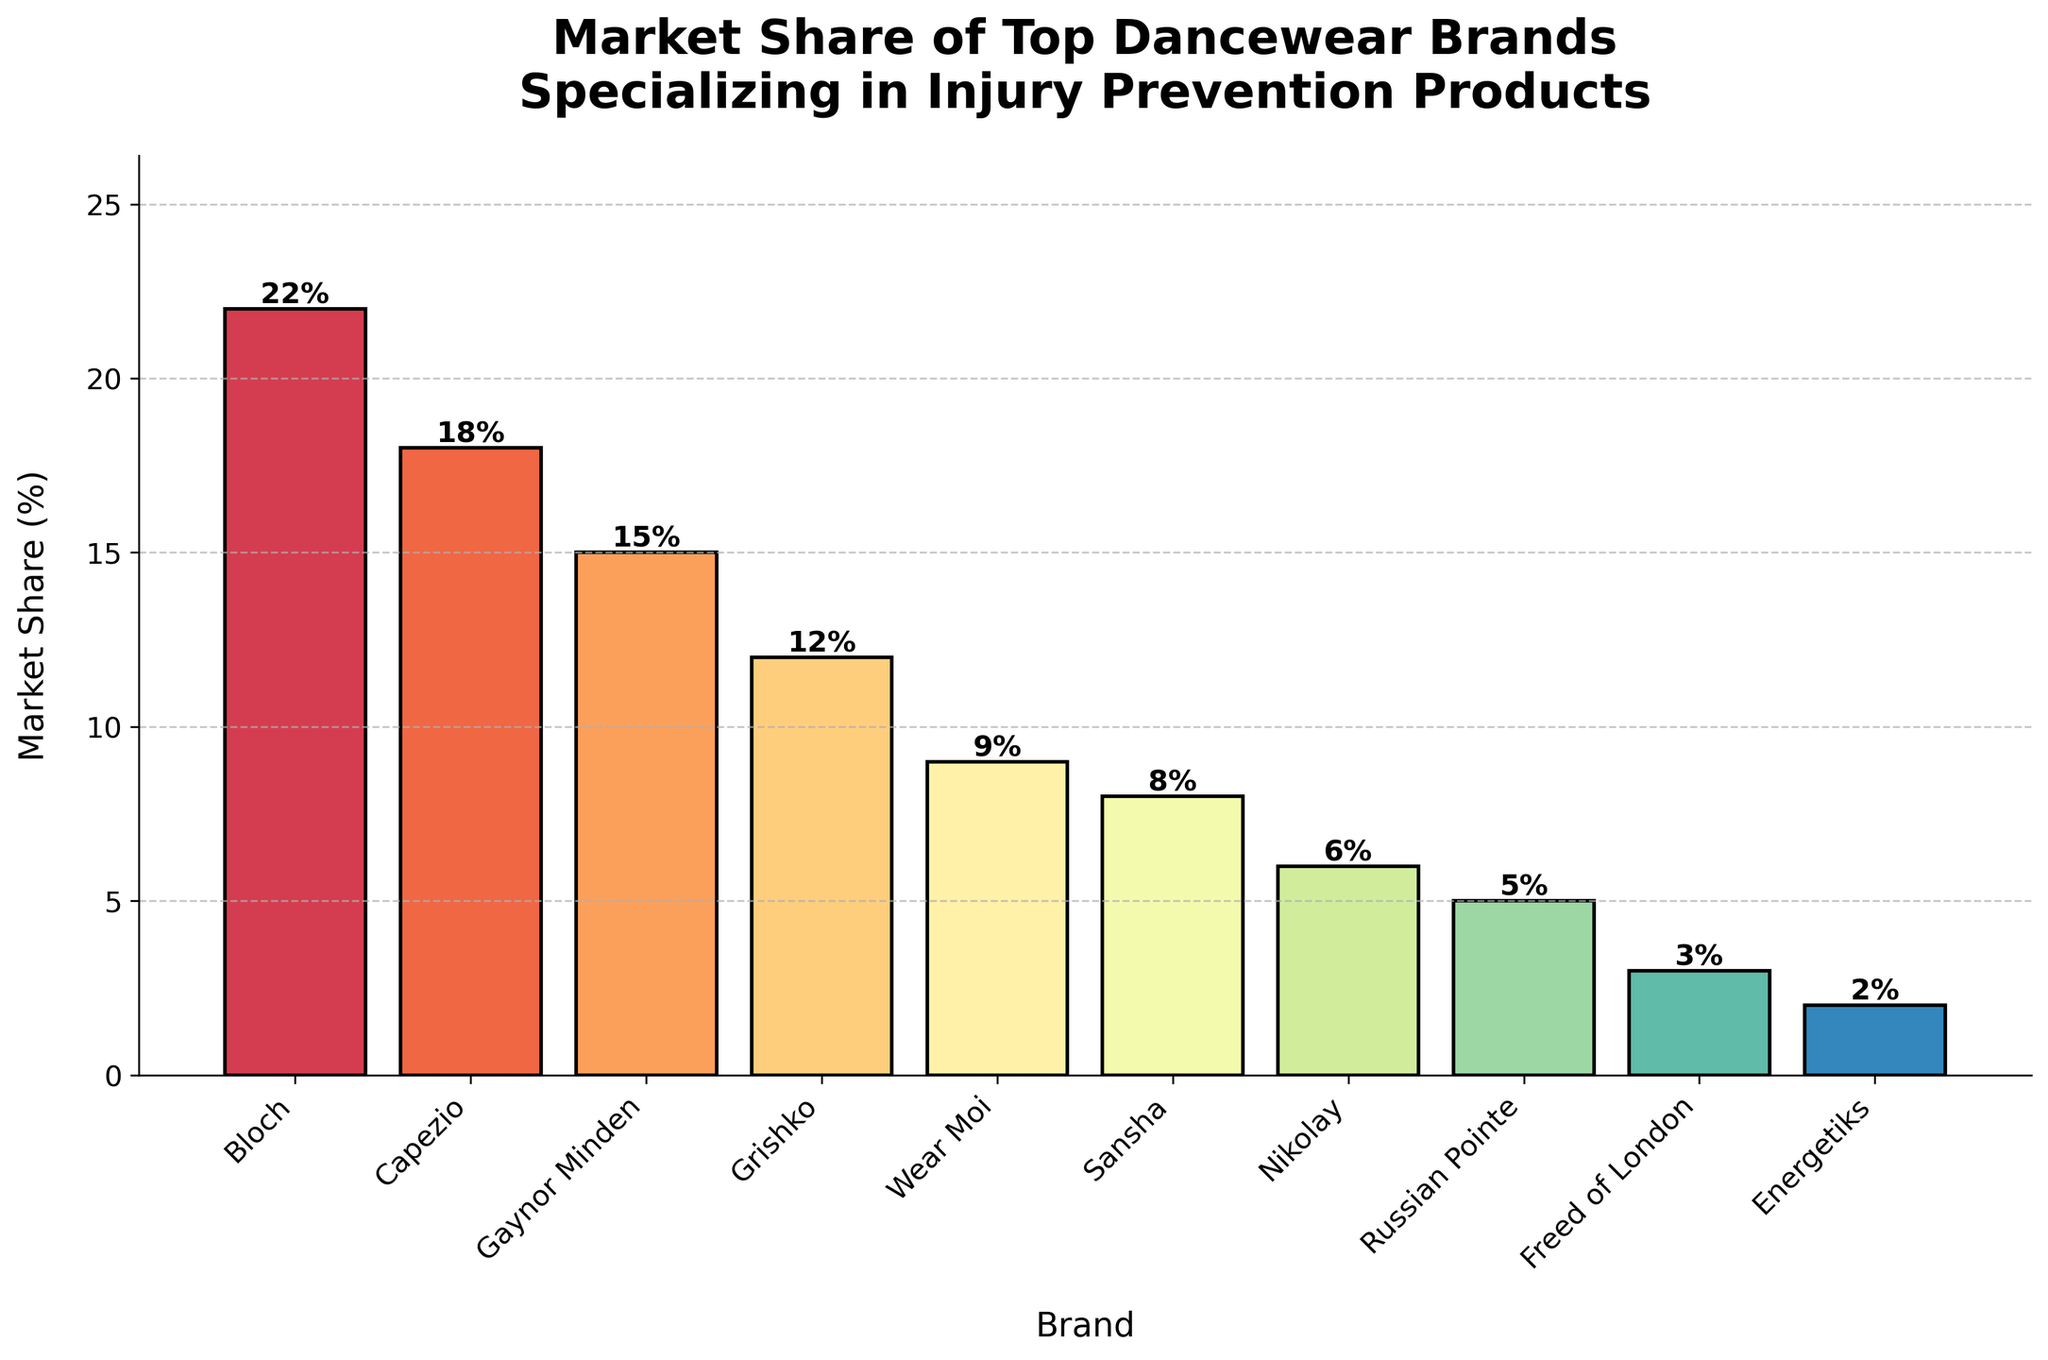Which brand has the largest market share? The tallest bar on the chart represents the brand with the largest market share. Bloch has the tallest bar.
Answer: Bloch What is the combined market share of Capezio and Wear Moi? Capezio has an 18% market share, and Wear Moi has a 9% market share. Adding them together: 18% + 9% = 27%.
Answer: 27% Which brand has the smallest market share? The shortest bar on the chart represents the brand with the smallest market share. Energetiks has the shortest bar.
Answer: Energetiks How much larger is Bloch's market share compared to Sansha's market share? Subtract the market share of Sansha (8%) from Bloch's market share (22%): 22% - 8% = 14%.
Answer: 14% What is the average market share of Gaynor Minden, Grishko, and Russian Pointe? Their market shares are 15%, 12%, and 5% respectively. Summing them: 15% + 12% + 5% = 32%. Then, dividing by the number of data points: 32% / 3 = ~10.67%.
Answer: ~10.67% Which brands have a market share greater than 10%? Bloch, Capezio, and Gaynor Minden all have bars taller than 10%.
Answer: Bloch, Capezio, Gaynor Minden How many brands have a market share less than 5%? Freed of London and Energetiks both have market shares less than 5%.
Answer: 2 What is the difference in market share between Gaynor Minden and Nikolay? Subtract Nikolay's market share (6%) from Gaynor Minden's market share (15%): 15% - 6% = 9%.
Answer: 9% Which three brands have the middle market shares? Arranging in ascending order: Energetiks, Freed of London, Russian Pointe, Nikolay, Sansha, Wear Moi, Grishko, Gaynor Minden, Capezio, Bloch. The middle three are Grishko, Sansha, and Wear Moi.
Answer: Grishko, Sansha, Wear Moi Is the market share of Grishko closer to that of Wear Moi or Capezio? Grishko's market share is 12%. Wear Moi's market share is 9%, and Capezio's market share is 18%. The difference with Wear Moi is 12 - 9 = 3%. The difference with Capezio is 18 - 12 = 6%. Grishko is closer to Wear Moi.
Answer: Wear Moi 